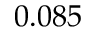Convert formula to latex. <formula><loc_0><loc_0><loc_500><loc_500>0 . 0 8 5</formula> 